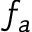Convert formula to latex. <formula><loc_0><loc_0><loc_500><loc_500>f _ { a }</formula> 